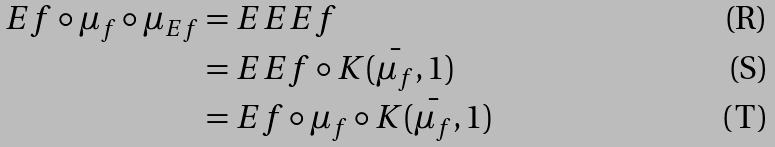<formula> <loc_0><loc_0><loc_500><loc_500>E f \circ \mu _ { f } \circ \mu _ { E f } & = E E E f \\ & = E E f \circ \bar { K ( \mu _ { f } , 1 ) } \\ & = E f \circ \mu _ { f } \circ \bar { K ( \mu _ { f } , 1 ) }</formula> 